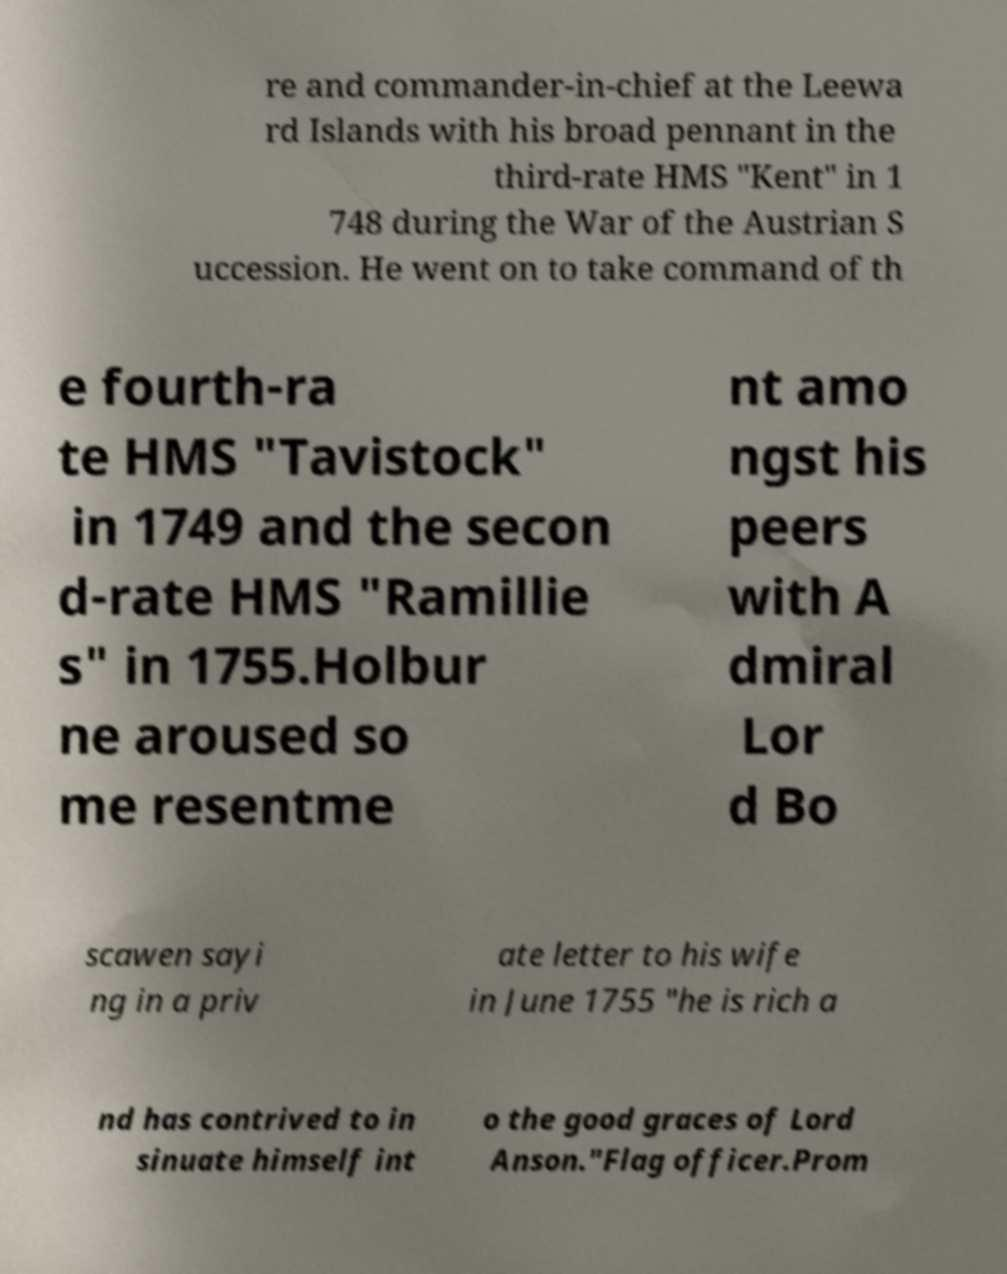There's text embedded in this image that I need extracted. Can you transcribe it verbatim? re and commander-in-chief at the Leewa rd Islands with his broad pennant in the third-rate HMS "Kent" in 1 748 during the War of the Austrian S uccession. He went on to take command of th e fourth-ra te HMS "Tavistock" in 1749 and the secon d-rate HMS "Ramillie s" in 1755.Holbur ne aroused so me resentme nt amo ngst his peers with A dmiral Lor d Bo scawen sayi ng in a priv ate letter to his wife in June 1755 "he is rich a nd has contrived to in sinuate himself int o the good graces of Lord Anson."Flag officer.Prom 